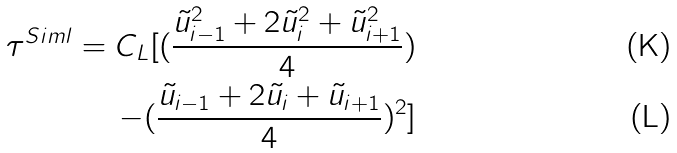<formula> <loc_0><loc_0><loc_500><loc_500>\tau ^ { S i m l } = C _ { L } [ ( { \frac { \tilde { u } _ { i - 1 } ^ { 2 } + 2 \tilde { u } _ { i } ^ { 2 } + \tilde { u } _ { i + 1 } ^ { 2 } } { 4 } } ) \\ - ( { \frac { \tilde { u } _ { i - 1 } + 2 \tilde { u } _ { i } + \tilde { u } _ { i + 1 } } { 4 } } ) ^ { 2 } ]</formula> 